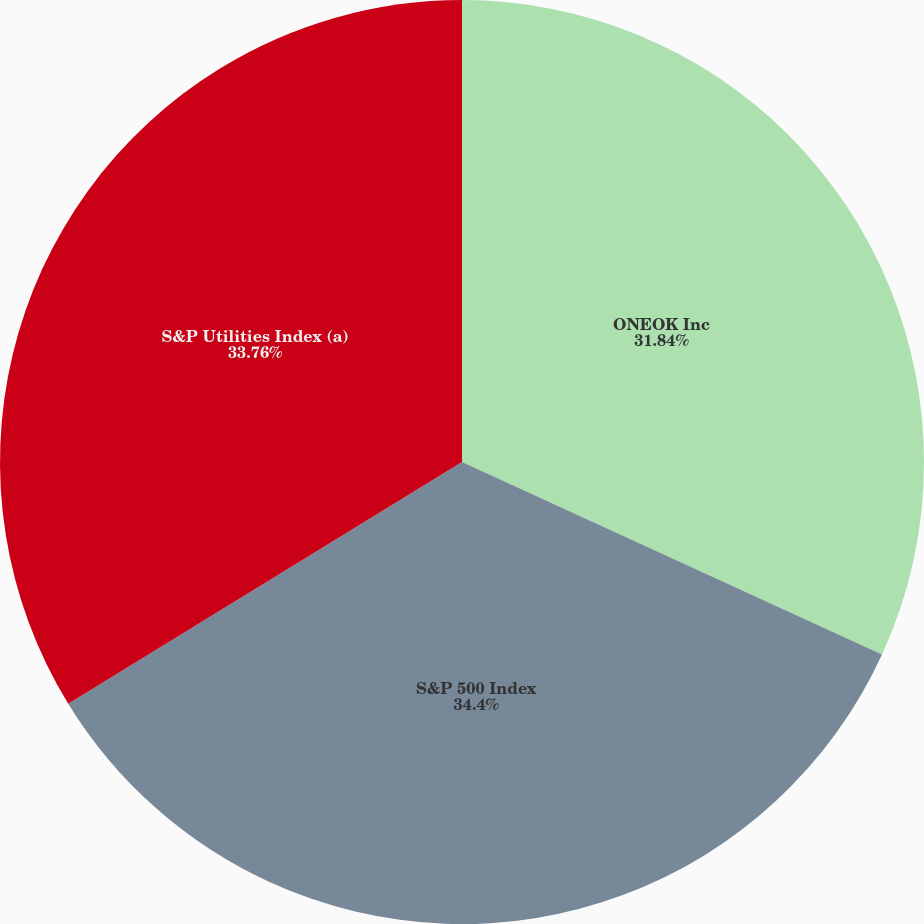Convert chart. <chart><loc_0><loc_0><loc_500><loc_500><pie_chart><fcel>ONEOK Inc<fcel>S&P 500 Index<fcel>S&P Utilities Index (a)<nl><fcel>31.84%<fcel>34.4%<fcel>33.76%<nl></chart> 